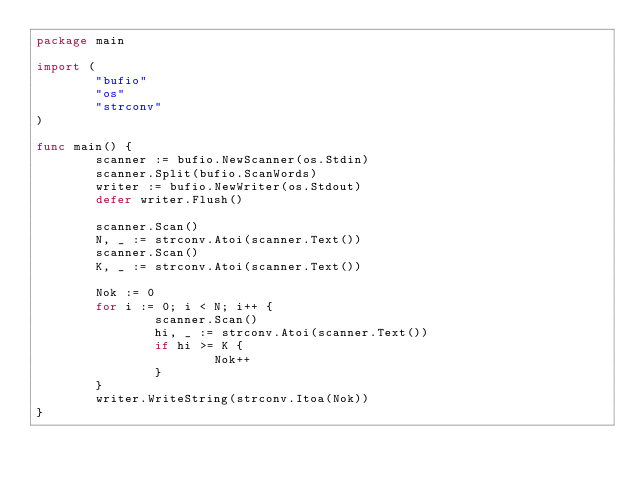<code> <loc_0><loc_0><loc_500><loc_500><_Go_>package main

import (
        "bufio"
        "os"
        "strconv"
)

func main() {
        scanner := bufio.NewScanner(os.Stdin)
        scanner.Split(bufio.ScanWords)
        writer := bufio.NewWriter(os.Stdout)
        defer writer.Flush()

        scanner.Scan()
        N, _ := strconv.Atoi(scanner.Text())
        scanner.Scan()
        K, _ := strconv.Atoi(scanner.Text())

        Nok := 0
        for i := 0; i < N; i++ {
                scanner.Scan()
                hi, _ := strconv.Atoi(scanner.Text())
                if hi >= K {
                        Nok++
                }
        }
        writer.WriteString(strconv.Itoa(Nok))
}
</code> 